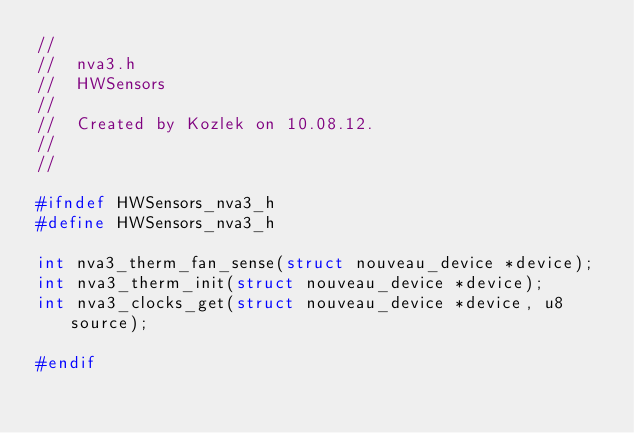Convert code to text. <code><loc_0><loc_0><loc_500><loc_500><_C_>//
//  nva3.h
//  HWSensors
//
//  Created by Kozlek on 10.08.12.
//
//

#ifndef HWSensors_nva3_h
#define HWSensors_nva3_h

int nva3_therm_fan_sense(struct nouveau_device *device);
int nva3_therm_init(struct nouveau_device *device);
int nva3_clocks_get(struct nouveau_device *device, u8 source);

#endif
</code> 